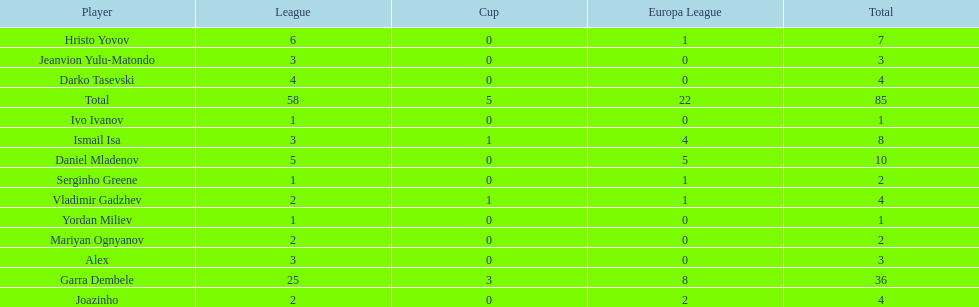How many players did not score a goal in cup play? 10. Parse the table in full. {'header': ['Player', 'League', 'Cup', 'Europa League', 'Total'], 'rows': [['Hristo Yovov', '6', '0', '1', '7'], ['Jeanvion Yulu-Matondo', '3', '0', '0', '3'], ['Darko Tasevski', '4', '0', '0', '4'], ['Total', '58', '5', '22', '85'], ['Ivo Ivanov', '1', '0', '0', '1'], ['Ismail Isa', '3', '1', '4', '8'], ['Daniel Mladenov', '5', '0', '5', '10'], ['Serginho Greene', '1', '0', '1', '2'], ['Vladimir Gadzhev', '2', '1', '1', '4'], ['Yordan Miliev', '1', '0', '0', '1'], ['Mariyan Ognyanov', '2', '0', '0', '2'], ['Alex', '3', '0', '0', '3'], ['Garra Dembele', '25', '3', '8', '36'], ['Joazinho', '2', '0', '2', '4']]} 